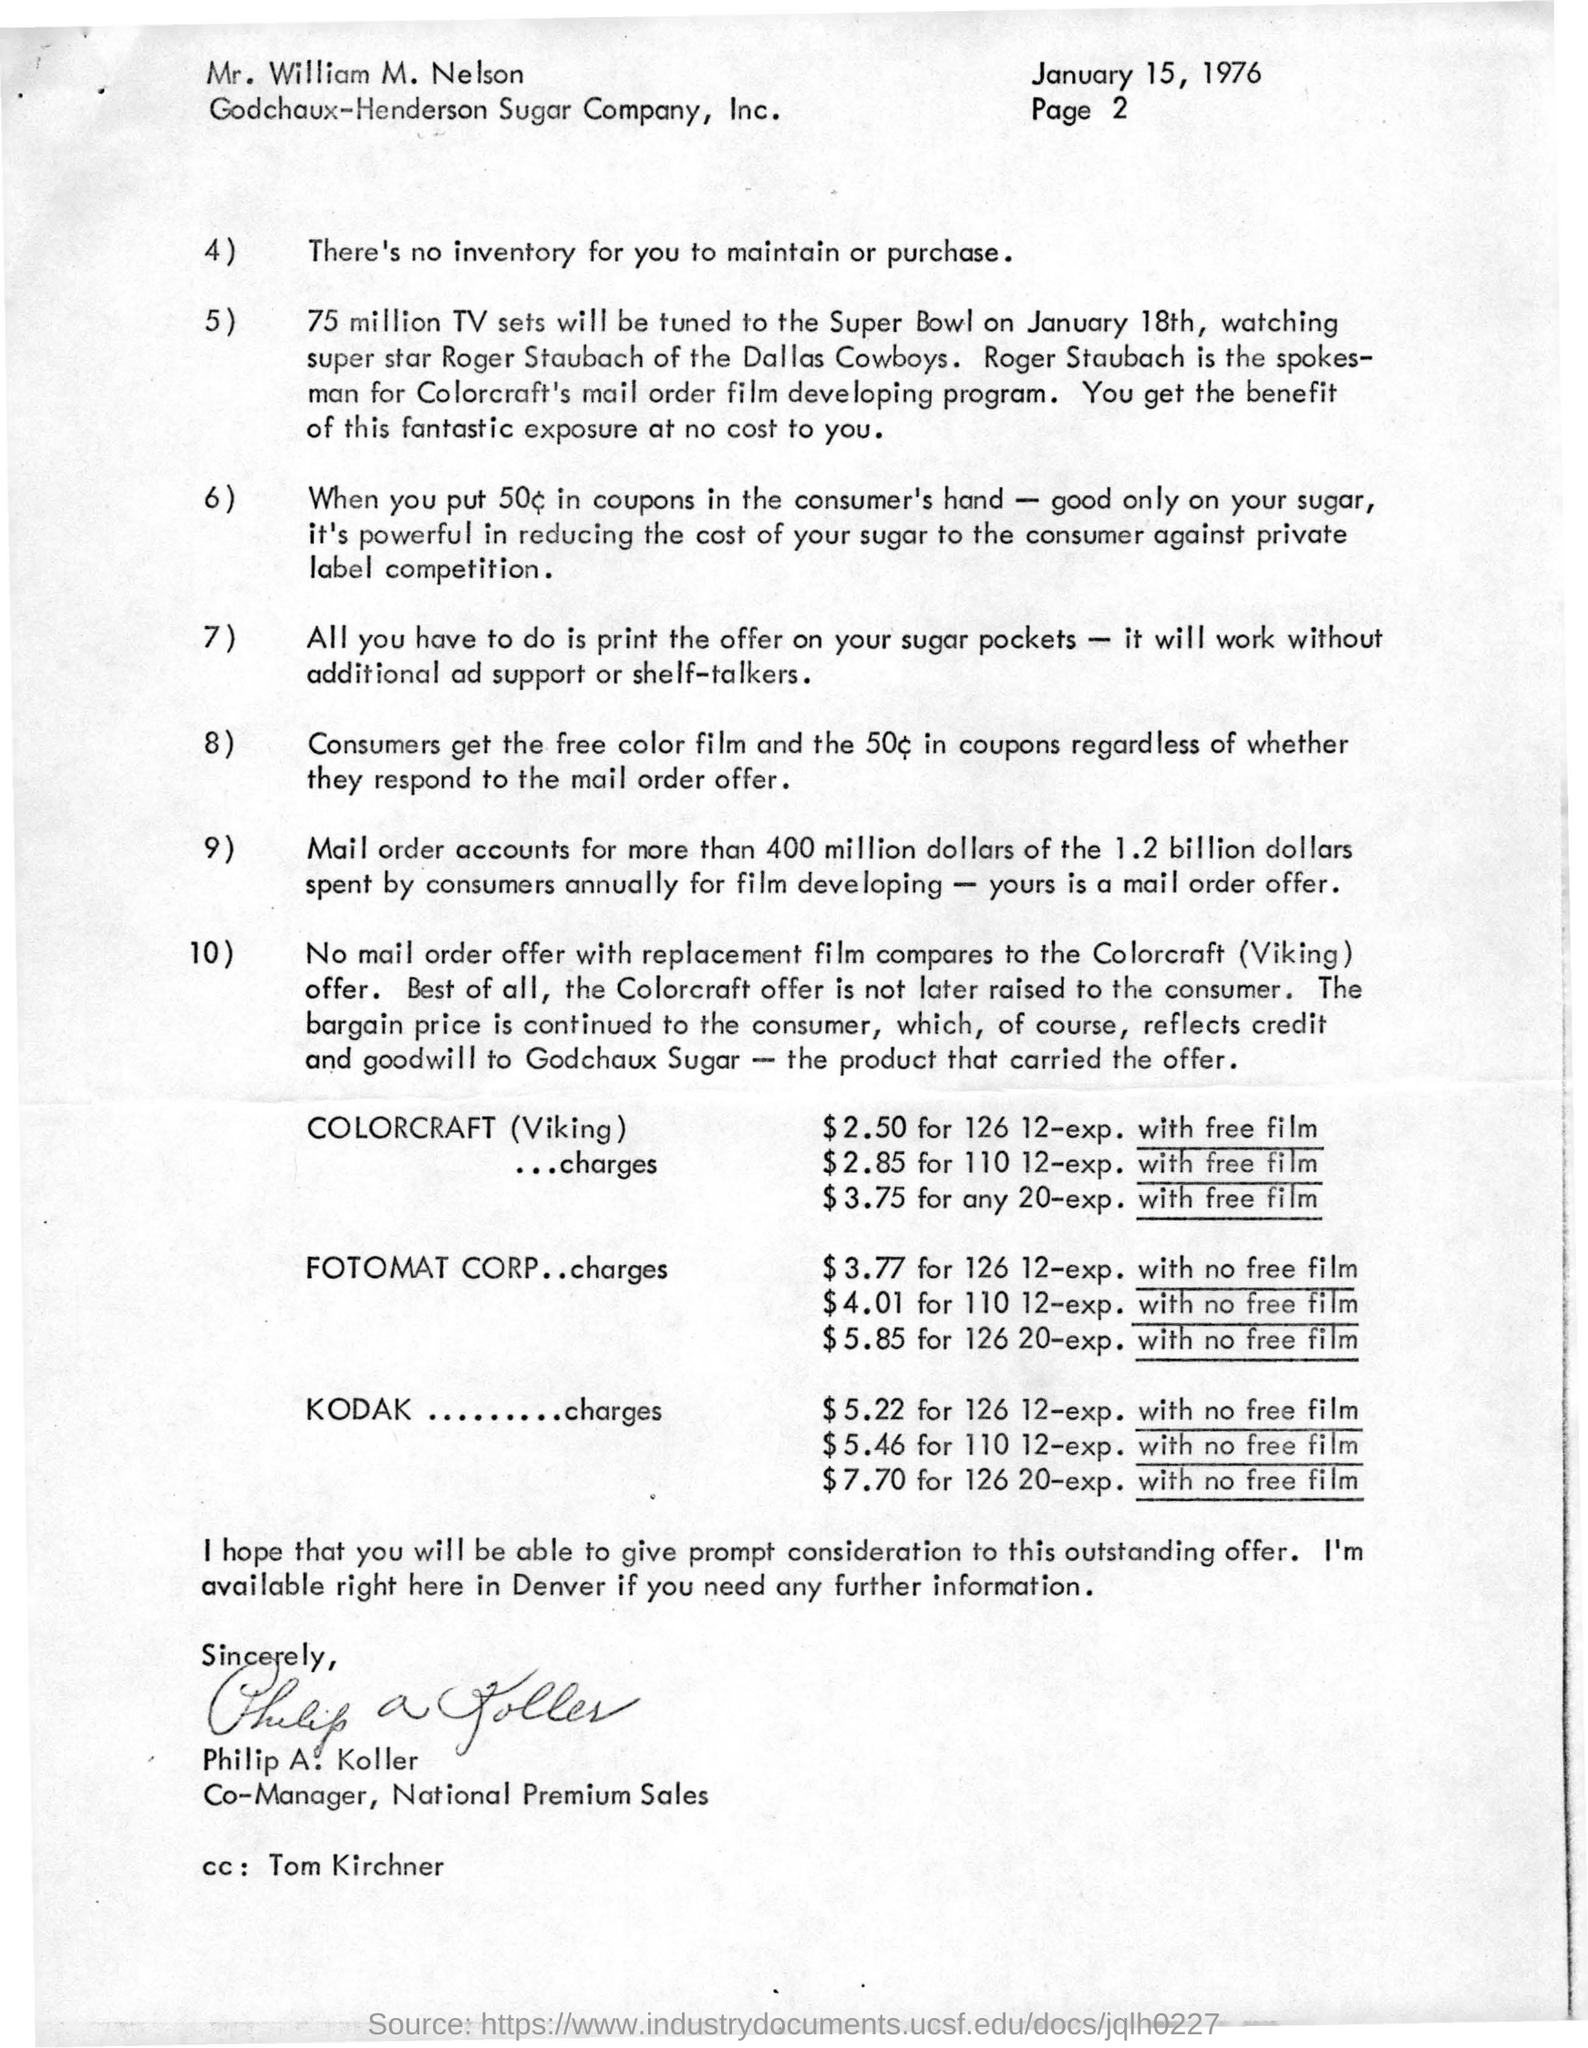List a handful of essential elements in this visual. Roger Staubach is the spokesperson for Colorcraft's mail order film developing program. The letter is addressed to Mr. William M. Nelson. The letter was written by Philip A. Koller. 